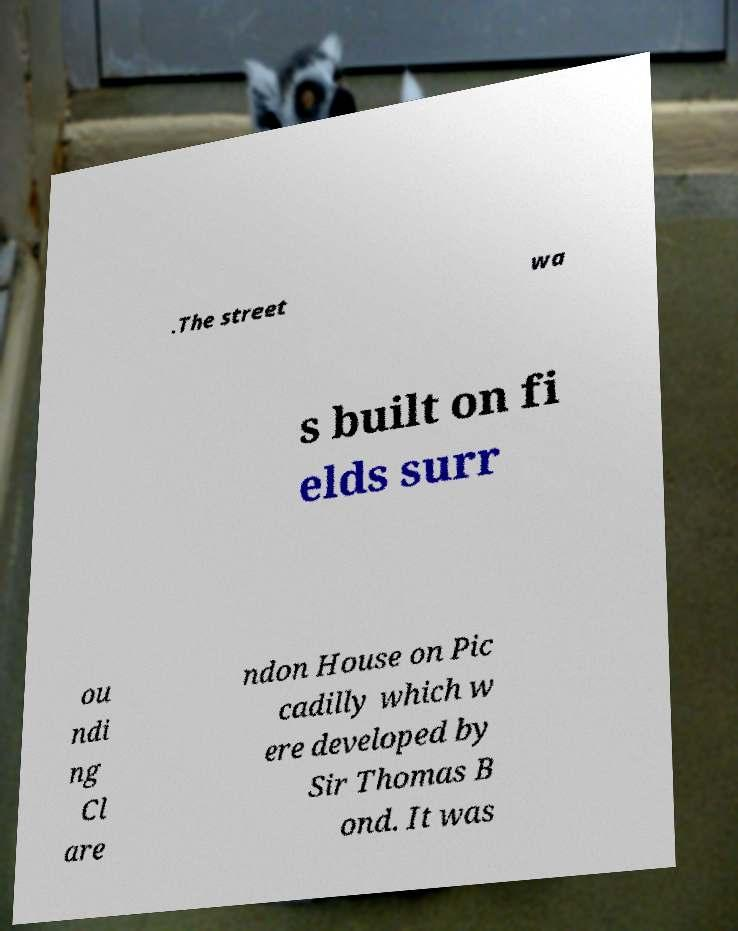Please read and relay the text visible in this image. What does it say? .The street wa s built on fi elds surr ou ndi ng Cl are ndon House on Pic cadilly which w ere developed by Sir Thomas B ond. It was 